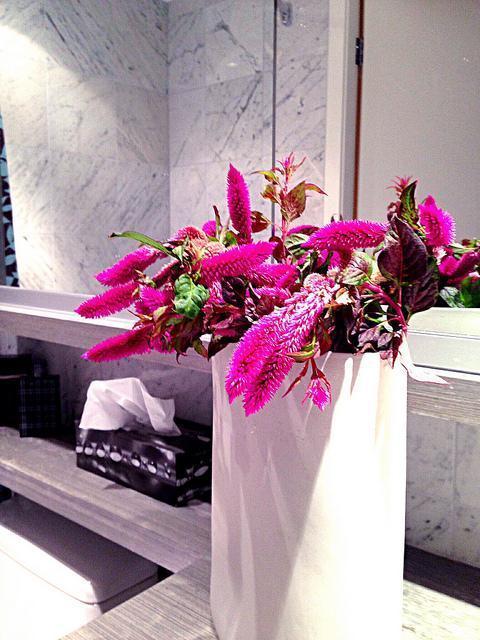How many flower vases?
Give a very brief answer. 1. How many vases are there?
Give a very brief answer. 1. How many people are in the water?
Give a very brief answer. 0. 